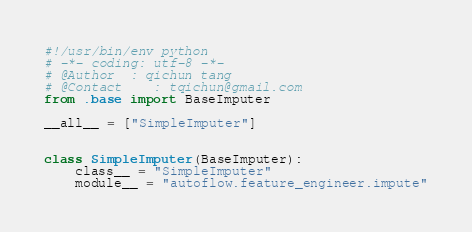<code> <loc_0><loc_0><loc_500><loc_500><_Python_>#!/usr/bin/env python
# -*- coding: utf-8 -*-
# @Author  : qichun tang
# @Contact    : tqichun@gmail.com
from .base import BaseImputer

__all__ = ["SimpleImputer"]


class SimpleImputer(BaseImputer):
    class__ = "SimpleImputer"
    module__ = "autoflow.feature_engineer.impute"
</code> 